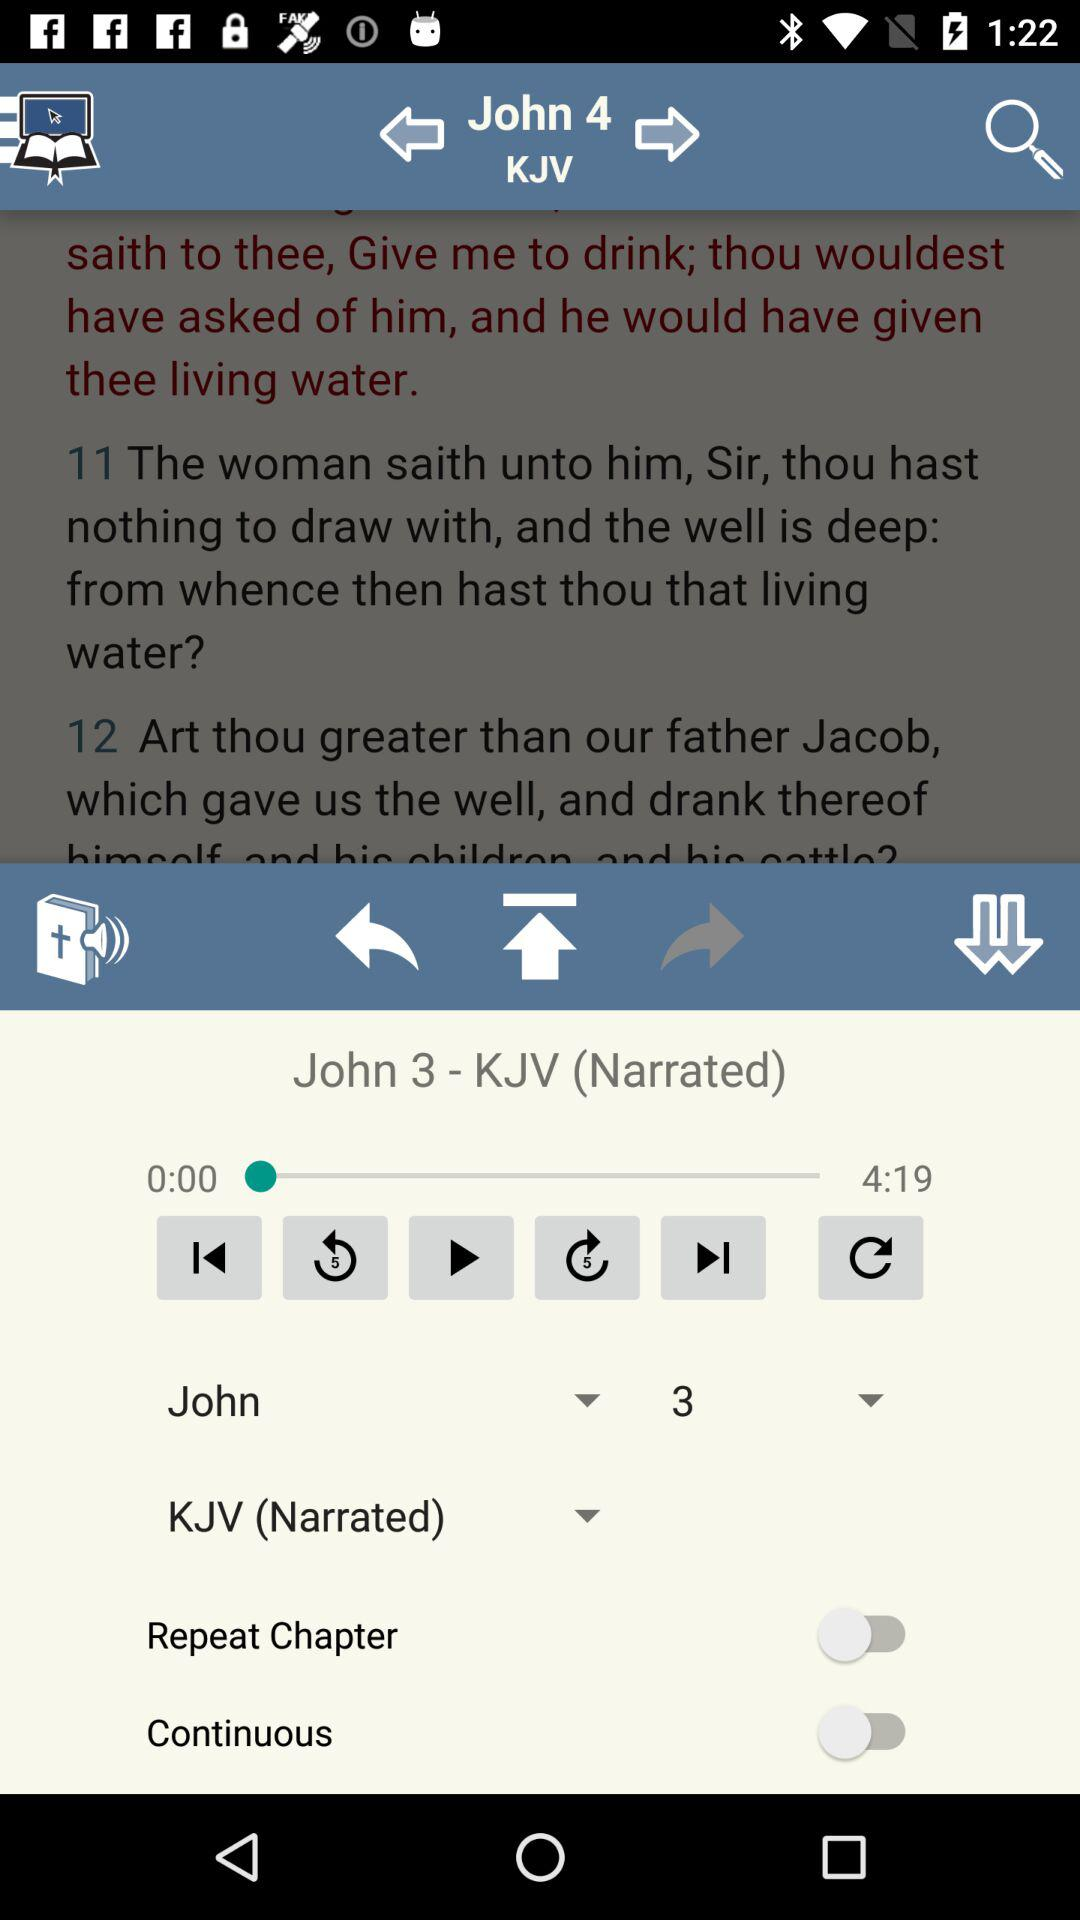What is the status of "Continuous"? The status of "Continuous" is "off". 